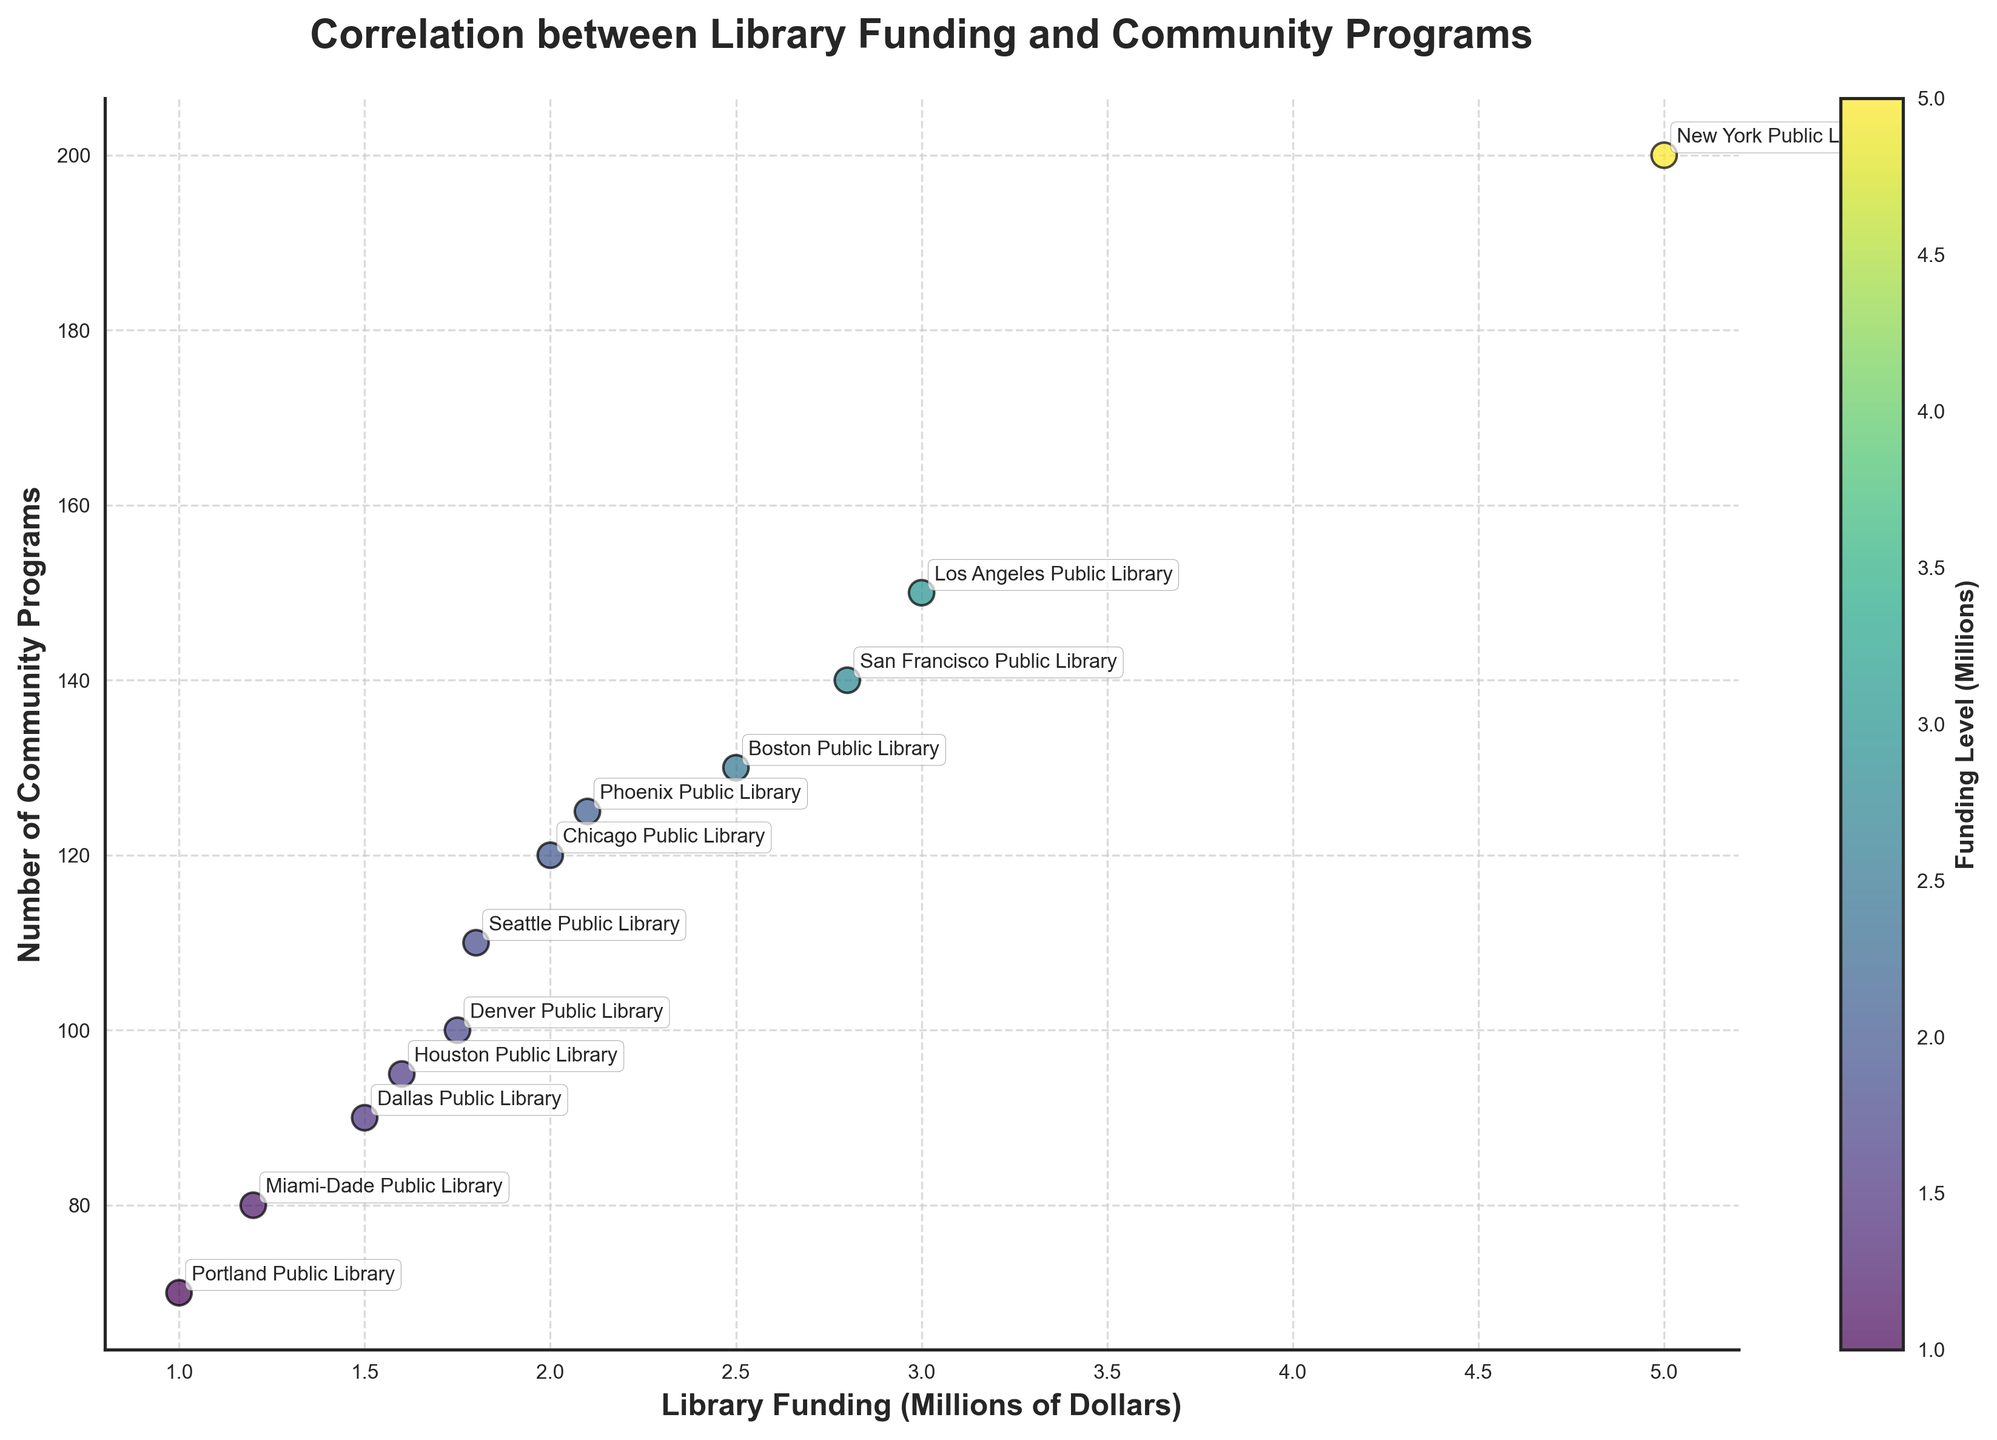What is the title of the scatter plot? The title of the plot is written at the top and summarizes the relationship being examined. The title of the plot is "Correlation between Library Funding and Community Programs".
Answer: Correlation between Library Funding and Community Programs How many libraries are represented in the scatter plot? To find the number of libraries, count the number of data points in the scatter plot. There are 12 libraries represented.
Answer: 12 What are the ranges of the x-axis and y-axis? The x-axis represents funding levels and the y-axis represents the number of community programs. The range of the x-axis (funding) is from 1 to 5 million dollars, and the range of the y-axis (community programs) is from 70 to 200.
Answer: 1 to 5 million (x-axis), 70 to 200 (y-axis) Which library has the highest number of community programs? The New York Public Library has the highest number of community programs because its data point is the highest on the y-axis.
Answer: New York Public Library Is there a positive or negative correlation between library funding levels and the number of community programs offered? By observing the trend of the data points, as the funding level increases, the number of community programs also tends to increase, suggesting a positive correlation.
Answer: Positive What can you say about the library with the lowest funding level? The Portland Public Library has the lowest funding level at 1 million dollars, and it offers 70 community programs. This is the data point located closest to the origin on both axes.
Answer: Portland Public Library offers 70 programs Which library has the closest funding level to 2 million dollars? The Chicago Public Library and the Phoenix Public Library both have funding levels around 2 million dollars. The Chicago Public Library is very close to exactly 2 million dollars.
Answer: Chicago Public Library How many libraries have more than 100 community programs but less than 2 million dollars in funding? Locate the data points with more than 100 community programs and less than 2 million dollars in funding. The libraries are Seattle Public Library (110 programs) and Denver Public Library (100 programs).
Answer: 2 Which libraries have funding levels between 1.5 million and 2 million dollars? Identify data points within the specified funding range. Dallas Public Library (1.5 million dollars) and Seattle Public Library (1.8 million dollars) fit this criterion.
Answer: Dallas Public Library, Seattle Public Library 